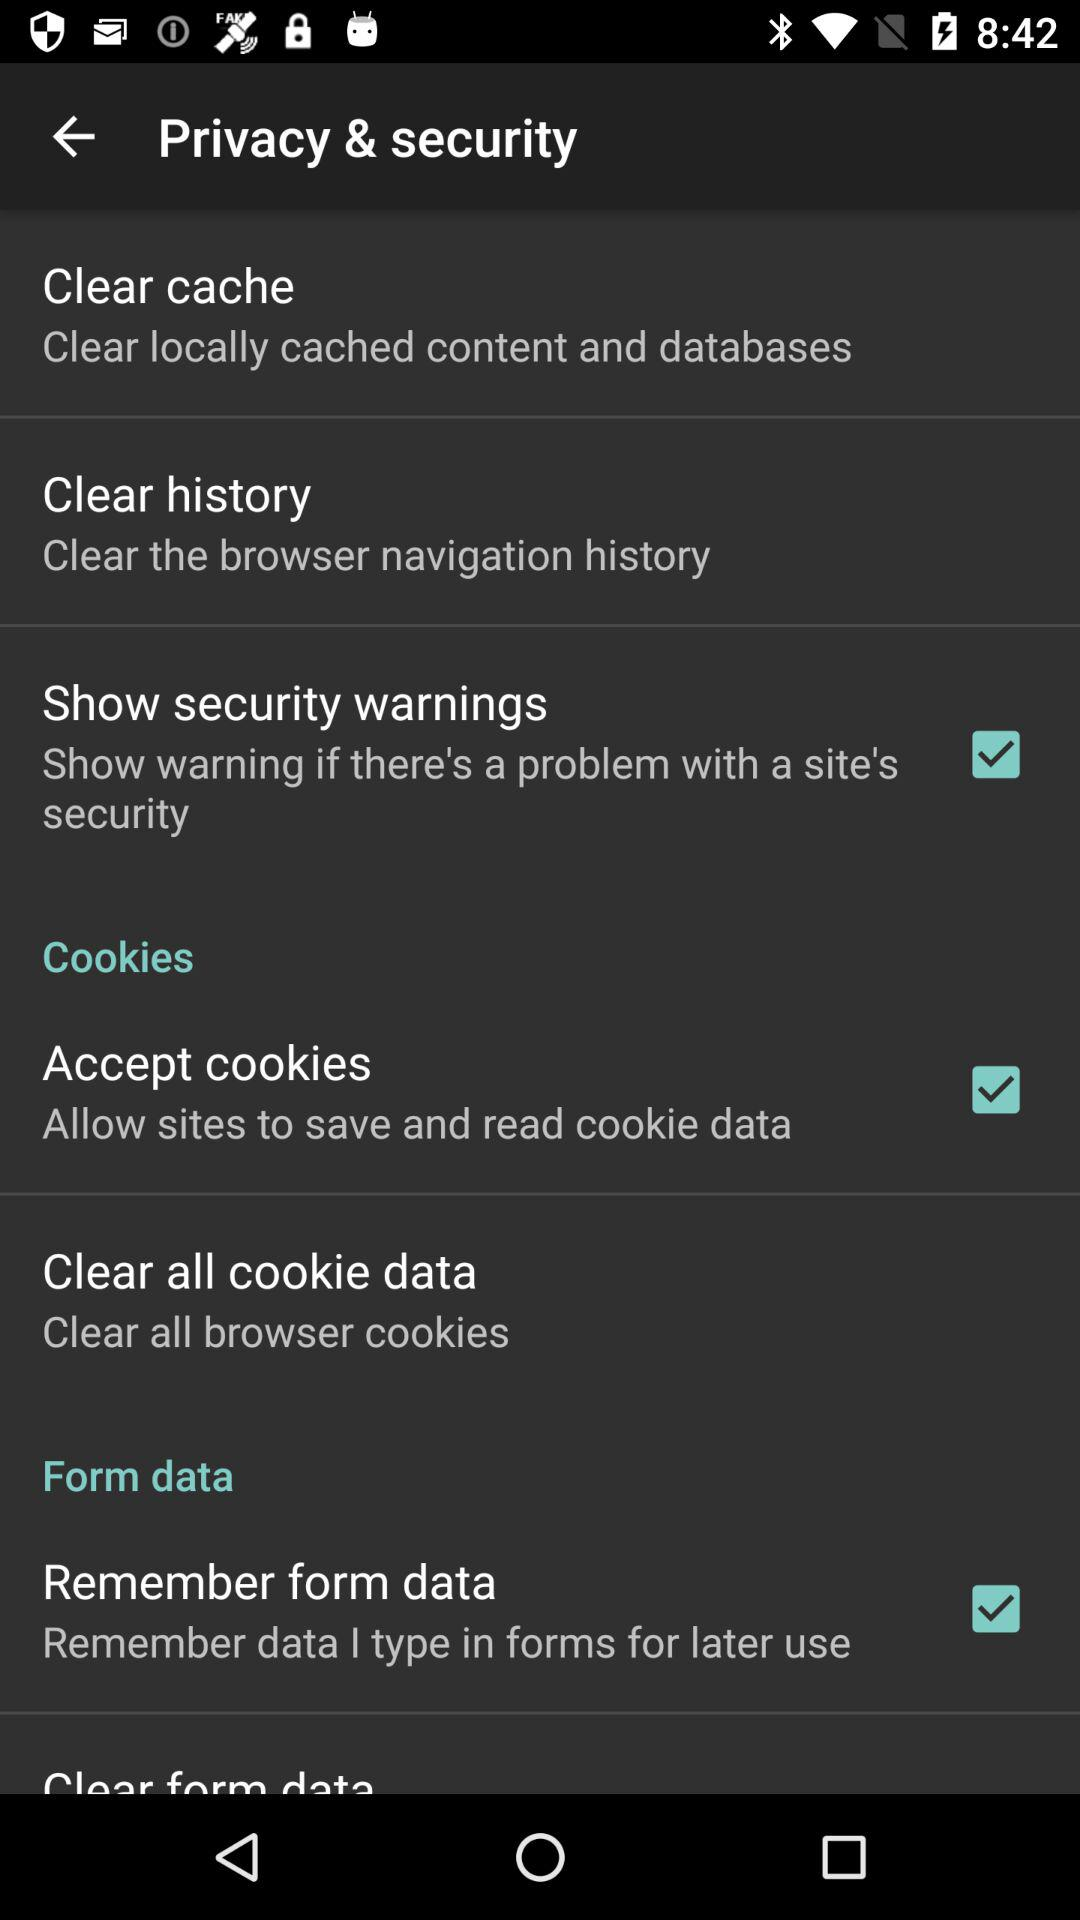What data is allowed to Remember?
When the provided information is insufficient, respond with <no answer>. <no answer> 